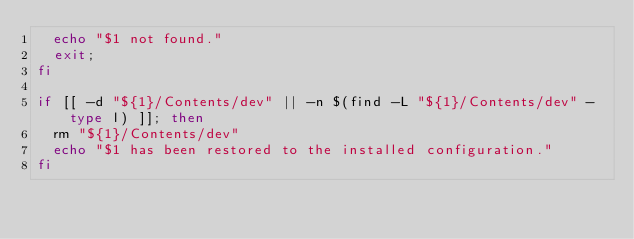<code> <loc_0><loc_0><loc_500><loc_500><_Bash_>  echo "$1 not found."
  exit;
fi

if [[ -d "${1}/Contents/dev" || -n $(find -L "${1}/Contents/dev" -type l) ]]; then
  rm "${1}/Contents/dev"
  echo "$1 has been restored to the installed configuration."
fi
</code> 